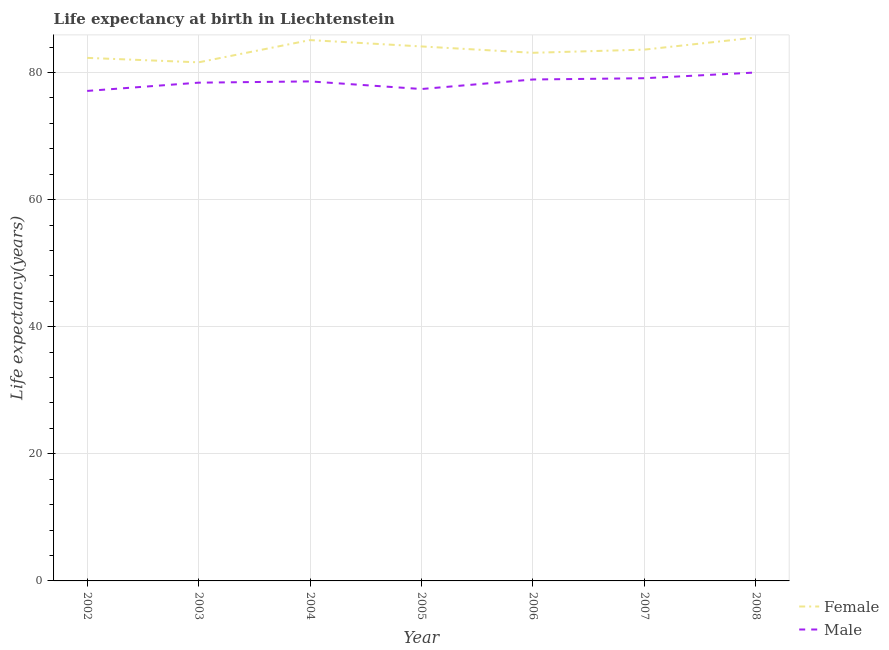Does the line corresponding to life expectancy(male) intersect with the line corresponding to life expectancy(female)?
Make the answer very short. No. What is the life expectancy(female) in 2002?
Your answer should be very brief. 82.3. Across all years, what is the maximum life expectancy(female)?
Keep it short and to the point. 85.5. Across all years, what is the minimum life expectancy(male)?
Your response must be concise. 77.1. In which year was the life expectancy(male) maximum?
Your answer should be very brief. 2008. In which year was the life expectancy(female) minimum?
Offer a terse response. 2003. What is the total life expectancy(female) in the graph?
Make the answer very short. 585.3. What is the difference between the life expectancy(female) in 2002 and that in 2004?
Your response must be concise. -2.8. What is the difference between the life expectancy(male) in 2008 and the life expectancy(female) in 2005?
Give a very brief answer. -4.1. What is the average life expectancy(female) per year?
Make the answer very short. 83.61. In the year 2004, what is the difference between the life expectancy(female) and life expectancy(male)?
Your response must be concise. 6.5. What is the ratio of the life expectancy(male) in 2006 to that in 2007?
Offer a very short reply. 1. Is the life expectancy(male) in 2003 less than that in 2006?
Your answer should be compact. Yes. What is the difference between the highest and the second highest life expectancy(female)?
Keep it short and to the point. 0.4. What is the difference between the highest and the lowest life expectancy(male)?
Your response must be concise. 2.9. Is the life expectancy(male) strictly less than the life expectancy(female) over the years?
Your answer should be very brief. Yes. How are the legend labels stacked?
Offer a very short reply. Vertical. What is the title of the graph?
Your response must be concise. Life expectancy at birth in Liechtenstein. Does "Passenger Transport Items" appear as one of the legend labels in the graph?
Make the answer very short. No. What is the label or title of the Y-axis?
Your answer should be very brief. Life expectancy(years). What is the Life expectancy(years) of Female in 2002?
Offer a terse response. 82.3. What is the Life expectancy(years) in Male in 2002?
Provide a succinct answer. 77.1. What is the Life expectancy(years) of Female in 2003?
Provide a short and direct response. 81.6. What is the Life expectancy(years) in Male in 2003?
Your answer should be very brief. 78.4. What is the Life expectancy(years) in Female in 2004?
Offer a very short reply. 85.1. What is the Life expectancy(years) of Male in 2004?
Provide a succinct answer. 78.6. What is the Life expectancy(years) of Female in 2005?
Make the answer very short. 84.1. What is the Life expectancy(years) of Male in 2005?
Ensure brevity in your answer.  77.4. What is the Life expectancy(years) in Female in 2006?
Your answer should be very brief. 83.1. What is the Life expectancy(years) of Male in 2006?
Provide a succinct answer. 78.9. What is the Life expectancy(years) in Female in 2007?
Keep it short and to the point. 83.6. What is the Life expectancy(years) in Male in 2007?
Provide a short and direct response. 79.1. What is the Life expectancy(years) in Female in 2008?
Make the answer very short. 85.5. What is the Life expectancy(years) in Male in 2008?
Your answer should be compact. 80. Across all years, what is the maximum Life expectancy(years) in Female?
Keep it short and to the point. 85.5. Across all years, what is the minimum Life expectancy(years) in Female?
Your answer should be very brief. 81.6. Across all years, what is the minimum Life expectancy(years) in Male?
Offer a terse response. 77.1. What is the total Life expectancy(years) of Female in the graph?
Make the answer very short. 585.3. What is the total Life expectancy(years) in Male in the graph?
Make the answer very short. 549.5. What is the difference between the Life expectancy(years) of Female in 2002 and that in 2003?
Make the answer very short. 0.7. What is the difference between the Life expectancy(years) in Male in 2002 and that in 2003?
Make the answer very short. -1.3. What is the difference between the Life expectancy(years) of Female in 2002 and that in 2004?
Offer a very short reply. -2.8. What is the difference between the Life expectancy(years) of Male in 2002 and that in 2006?
Offer a very short reply. -1.8. What is the difference between the Life expectancy(years) in Male in 2003 and that in 2004?
Keep it short and to the point. -0.2. What is the difference between the Life expectancy(years) of Male in 2003 and that in 2007?
Give a very brief answer. -0.7. What is the difference between the Life expectancy(years) of Female in 2003 and that in 2008?
Offer a terse response. -3.9. What is the difference between the Life expectancy(years) of Male in 2003 and that in 2008?
Your response must be concise. -1.6. What is the difference between the Life expectancy(years) in Male in 2004 and that in 2005?
Your response must be concise. 1.2. What is the difference between the Life expectancy(years) of Female in 2004 and that in 2006?
Your response must be concise. 2. What is the difference between the Life expectancy(years) in Female in 2004 and that in 2007?
Offer a terse response. 1.5. What is the difference between the Life expectancy(years) in Male in 2004 and that in 2008?
Provide a short and direct response. -1.4. What is the difference between the Life expectancy(years) in Male in 2005 and that in 2006?
Provide a succinct answer. -1.5. What is the difference between the Life expectancy(years) in Female in 2005 and that in 2007?
Your response must be concise. 0.5. What is the difference between the Life expectancy(years) of Male in 2005 and that in 2007?
Ensure brevity in your answer.  -1.7. What is the difference between the Life expectancy(years) in Female in 2005 and that in 2008?
Provide a short and direct response. -1.4. What is the difference between the Life expectancy(years) in Male in 2005 and that in 2008?
Offer a terse response. -2.6. What is the difference between the Life expectancy(years) of Male in 2006 and that in 2008?
Provide a short and direct response. -1.1. What is the difference between the Life expectancy(years) of Female in 2007 and that in 2008?
Provide a short and direct response. -1.9. What is the difference between the Life expectancy(years) in Male in 2007 and that in 2008?
Give a very brief answer. -0.9. What is the difference between the Life expectancy(years) of Female in 2002 and the Life expectancy(years) of Male in 2003?
Provide a succinct answer. 3.9. What is the difference between the Life expectancy(years) of Female in 2002 and the Life expectancy(years) of Male in 2005?
Offer a terse response. 4.9. What is the difference between the Life expectancy(years) in Female in 2002 and the Life expectancy(years) in Male in 2007?
Your answer should be compact. 3.2. What is the difference between the Life expectancy(years) in Female in 2004 and the Life expectancy(years) in Male in 2005?
Provide a succinct answer. 7.7. What is the difference between the Life expectancy(years) of Female in 2004 and the Life expectancy(years) of Male in 2006?
Your answer should be very brief. 6.2. What is the difference between the Life expectancy(years) in Female in 2004 and the Life expectancy(years) in Male in 2007?
Give a very brief answer. 6. What is the difference between the Life expectancy(years) in Female in 2004 and the Life expectancy(years) in Male in 2008?
Make the answer very short. 5.1. What is the difference between the Life expectancy(years) of Female in 2005 and the Life expectancy(years) of Male in 2007?
Provide a succinct answer. 5. What is the difference between the Life expectancy(years) in Female in 2005 and the Life expectancy(years) in Male in 2008?
Make the answer very short. 4.1. What is the average Life expectancy(years) in Female per year?
Give a very brief answer. 83.61. What is the average Life expectancy(years) in Male per year?
Offer a terse response. 78.5. In the year 2002, what is the difference between the Life expectancy(years) in Female and Life expectancy(years) in Male?
Provide a short and direct response. 5.2. In the year 2003, what is the difference between the Life expectancy(years) in Female and Life expectancy(years) in Male?
Offer a very short reply. 3.2. In the year 2004, what is the difference between the Life expectancy(years) in Female and Life expectancy(years) in Male?
Offer a very short reply. 6.5. In the year 2007, what is the difference between the Life expectancy(years) in Female and Life expectancy(years) in Male?
Offer a very short reply. 4.5. What is the ratio of the Life expectancy(years) of Female in 2002 to that in 2003?
Offer a terse response. 1.01. What is the ratio of the Life expectancy(years) in Male in 2002 to that in 2003?
Keep it short and to the point. 0.98. What is the ratio of the Life expectancy(years) of Female in 2002 to that in 2004?
Your response must be concise. 0.97. What is the ratio of the Life expectancy(years) in Male in 2002 to that in 2004?
Make the answer very short. 0.98. What is the ratio of the Life expectancy(years) of Female in 2002 to that in 2005?
Give a very brief answer. 0.98. What is the ratio of the Life expectancy(years) of Female in 2002 to that in 2006?
Make the answer very short. 0.99. What is the ratio of the Life expectancy(years) of Male in 2002 to that in 2006?
Your answer should be compact. 0.98. What is the ratio of the Life expectancy(years) of Female in 2002 to that in 2007?
Your answer should be compact. 0.98. What is the ratio of the Life expectancy(years) in Male in 2002 to that in 2007?
Your response must be concise. 0.97. What is the ratio of the Life expectancy(years) in Female in 2002 to that in 2008?
Provide a short and direct response. 0.96. What is the ratio of the Life expectancy(years) in Male in 2002 to that in 2008?
Offer a terse response. 0.96. What is the ratio of the Life expectancy(years) of Female in 2003 to that in 2004?
Your answer should be very brief. 0.96. What is the ratio of the Life expectancy(years) of Female in 2003 to that in 2005?
Ensure brevity in your answer.  0.97. What is the ratio of the Life expectancy(years) of Male in 2003 to that in 2005?
Your answer should be compact. 1.01. What is the ratio of the Life expectancy(years) of Female in 2003 to that in 2006?
Provide a succinct answer. 0.98. What is the ratio of the Life expectancy(years) of Female in 2003 to that in 2007?
Provide a succinct answer. 0.98. What is the ratio of the Life expectancy(years) in Female in 2003 to that in 2008?
Keep it short and to the point. 0.95. What is the ratio of the Life expectancy(years) of Male in 2003 to that in 2008?
Make the answer very short. 0.98. What is the ratio of the Life expectancy(years) of Female in 2004 to that in 2005?
Offer a very short reply. 1.01. What is the ratio of the Life expectancy(years) of Male in 2004 to that in 2005?
Provide a short and direct response. 1.02. What is the ratio of the Life expectancy(years) of Female in 2004 to that in 2006?
Provide a succinct answer. 1.02. What is the ratio of the Life expectancy(years) in Male in 2004 to that in 2006?
Offer a very short reply. 1. What is the ratio of the Life expectancy(years) in Female in 2004 to that in 2007?
Give a very brief answer. 1.02. What is the ratio of the Life expectancy(years) of Male in 2004 to that in 2007?
Your answer should be very brief. 0.99. What is the ratio of the Life expectancy(years) in Male in 2004 to that in 2008?
Ensure brevity in your answer.  0.98. What is the ratio of the Life expectancy(years) of Female in 2005 to that in 2006?
Ensure brevity in your answer.  1.01. What is the ratio of the Life expectancy(years) of Female in 2005 to that in 2007?
Offer a terse response. 1.01. What is the ratio of the Life expectancy(years) in Male in 2005 to that in 2007?
Keep it short and to the point. 0.98. What is the ratio of the Life expectancy(years) of Female in 2005 to that in 2008?
Offer a very short reply. 0.98. What is the ratio of the Life expectancy(years) of Male in 2005 to that in 2008?
Your answer should be compact. 0.97. What is the ratio of the Life expectancy(years) of Female in 2006 to that in 2007?
Provide a short and direct response. 0.99. What is the ratio of the Life expectancy(years) in Male in 2006 to that in 2007?
Provide a succinct answer. 1. What is the ratio of the Life expectancy(years) in Female in 2006 to that in 2008?
Offer a terse response. 0.97. What is the ratio of the Life expectancy(years) of Male in 2006 to that in 2008?
Provide a succinct answer. 0.99. What is the ratio of the Life expectancy(years) in Female in 2007 to that in 2008?
Make the answer very short. 0.98. What is the ratio of the Life expectancy(years) of Male in 2007 to that in 2008?
Give a very brief answer. 0.99. What is the difference between the highest and the second highest Life expectancy(years) in Male?
Offer a very short reply. 0.9. What is the difference between the highest and the lowest Life expectancy(years) in Female?
Provide a short and direct response. 3.9. 